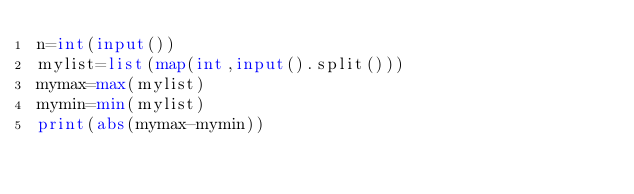Convert code to text. <code><loc_0><loc_0><loc_500><loc_500><_Python_>n=int(input())
mylist=list(map(int,input().split()))
mymax=max(mylist)
mymin=min(mylist)
print(abs(mymax-mymin))

</code> 